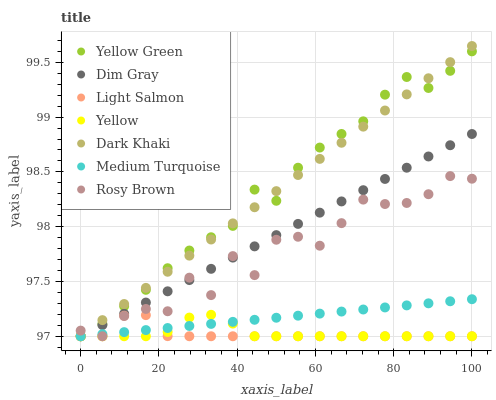Does Light Salmon have the minimum area under the curve?
Answer yes or no. Yes. Does Yellow Green have the maximum area under the curve?
Answer yes or no. Yes. Does Dim Gray have the minimum area under the curve?
Answer yes or no. No. Does Dim Gray have the maximum area under the curve?
Answer yes or no. No. Is Dark Khaki the smoothest?
Answer yes or no. Yes. Is Rosy Brown the roughest?
Answer yes or no. Yes. Is Dim Gray the smoothest?
Answer yes or no. No. Is Dim Gray the roughest?
Answer yes or no. No. Does Light Salmon have the lowest value?
Answer yes or no. Yes. Does Dark Khaki have the highest value?
Answer yes or no. Yes. Does Dim Gray have the highest value?
Answer yes or no. No. Does Rosy Brown intersect Dim Gray?
Answer yes or no. Yes. Is Rosy Brown less than Dim Gray?
Answer yes or no. No. Is Rosy Brown greater than Dim Gray?
Answer yes or no. No. 